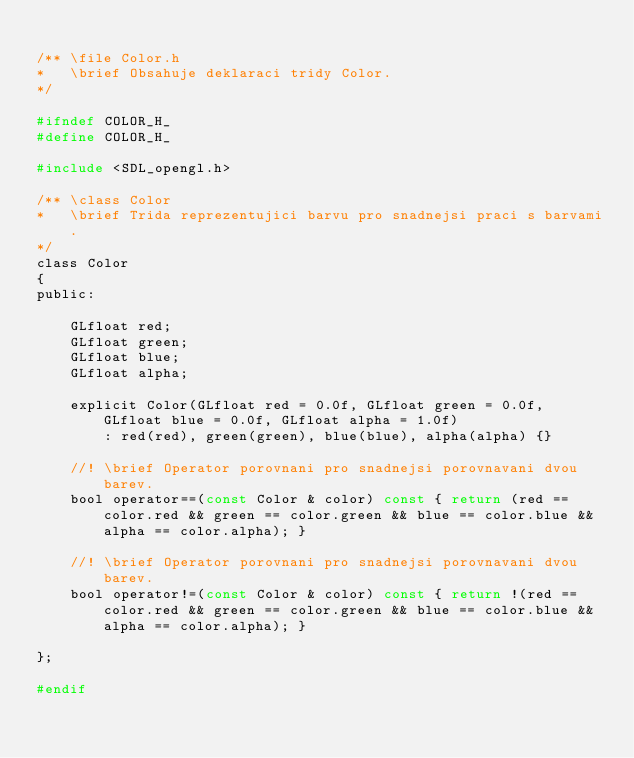Convert code to text. <code><loc_0><loc_0><loc_500><loc_500><_C_>
/** \file Color.h
*   \brief Obsahuje deklaraci tridy Color.
*/

#ifndef COLOR_H_
#define COLOR_H_

#include <SDL_opengl.h>

/** \class Color
*   \brief Trida reprezentujici barvu pro snadnejsi praci s barvami.
*/
class Color
{
public:

	GLfloat red; 
	GLfloat green; 
	GLfloat blue;  
	GLfloat alpha; 
 
	explicit Color(GLfloat red = 0.0f, GLfloat green = 0.0f, GLfloat blue = 0.0f, GLfloat alpha = 1.0f) 
		: red(red), green(green), blue(blue), alpha(alpha) {}

	//! \brief Operator porovnani pro snadnejsi porovnavani dvou barev. 
	bool operator==(const Color & color) const { return (red == color.red && green == color.green && blue == color.blue && alpha == color.alpha); }

	//! \brief Operator porovnani pro snadnejsi porovnavani dvou barev. 
	bool operator!=(const Color & color) const { return !(red == color.red && green == color.green && blue == color.blue && alpha == color.alpha); }

};

#endif</code> 